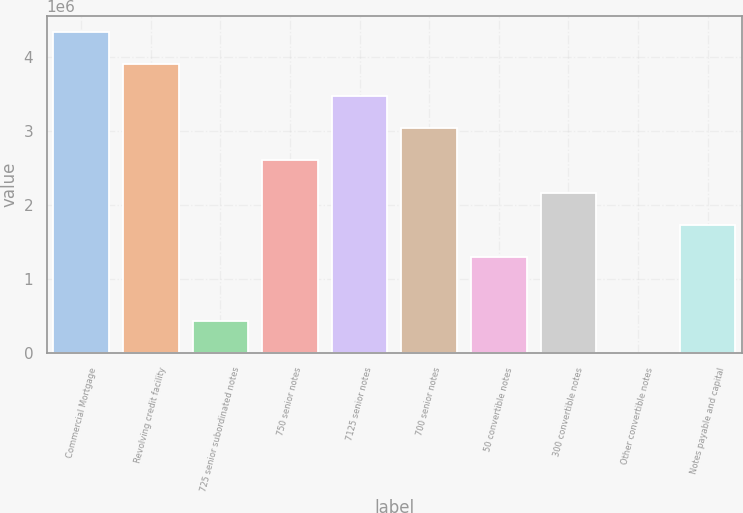Convert chart to OTSL. <chart><loc_0><loc_0><loc_500><loc_500><bar_chart><fcel>Commercial Mortgage<fcel>Revolving credit facility<fcel>725 senior subordinated notes<fcel>750 senior notes<fcel>7125 senior notes<fcel>700 senior notes<fcel>50 convertible notes<fcel>300 convertible notes<fcel>Other convertible notes<fcel>Notes payable and capital<nl><fcel>4.33315e+06<fcel>3.89984e+06<fcel>433352<fcel>2.5999e+06<fcel>3.46652e+06<fcel>3.03321e+06<fcel>1.29997e+06<fcel>2.16659e+06<fcel>41<fcel>1.73328e+06<nl></chart> 